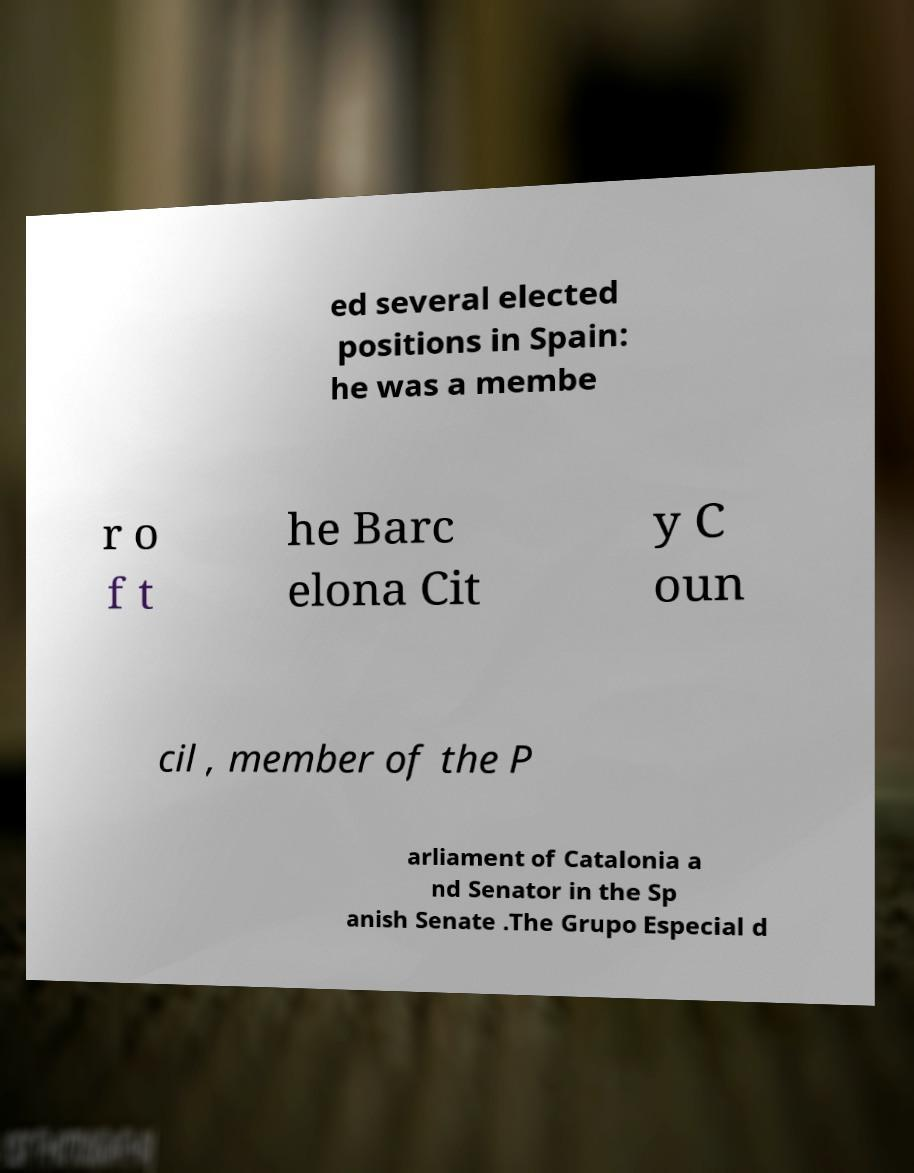Please identify and transcribe the text found in this image. ed several elected positions in Spain: he was a membe r o f t he Barc elona Cit y C oun cil , member of the P arliament of Catalonia a nd Senator in the Sp anish Senate .The Grupo Especial d 